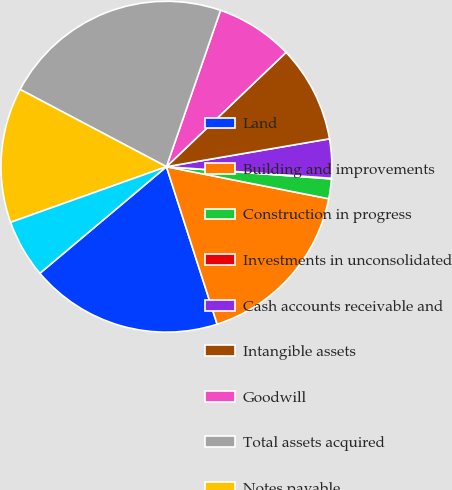Convert chart to OTSL. <chart><loc_0><loc_0><loc_500><loc_500><pie_chart><fcel>Land<fcel>Building and improvements<fcel>Construction in progress<fcel>Investments in unconsolidated<fcel>Cash accounts receivable and<fcel>Intangible assets<fcel>Goodwill<fcel>Total assets acquired<fcel>Notes payable<fcel>Accounts payable accrued<nl><fcel>18.82%<fcel>16.94%<fcel>1.93%<fcel>0.06%<fcel>3.81%<fcel>9.44%<fcel>7.56%<fcel>22.57%<fcel>13.19%<fcel>5.68%<nl></chart> 